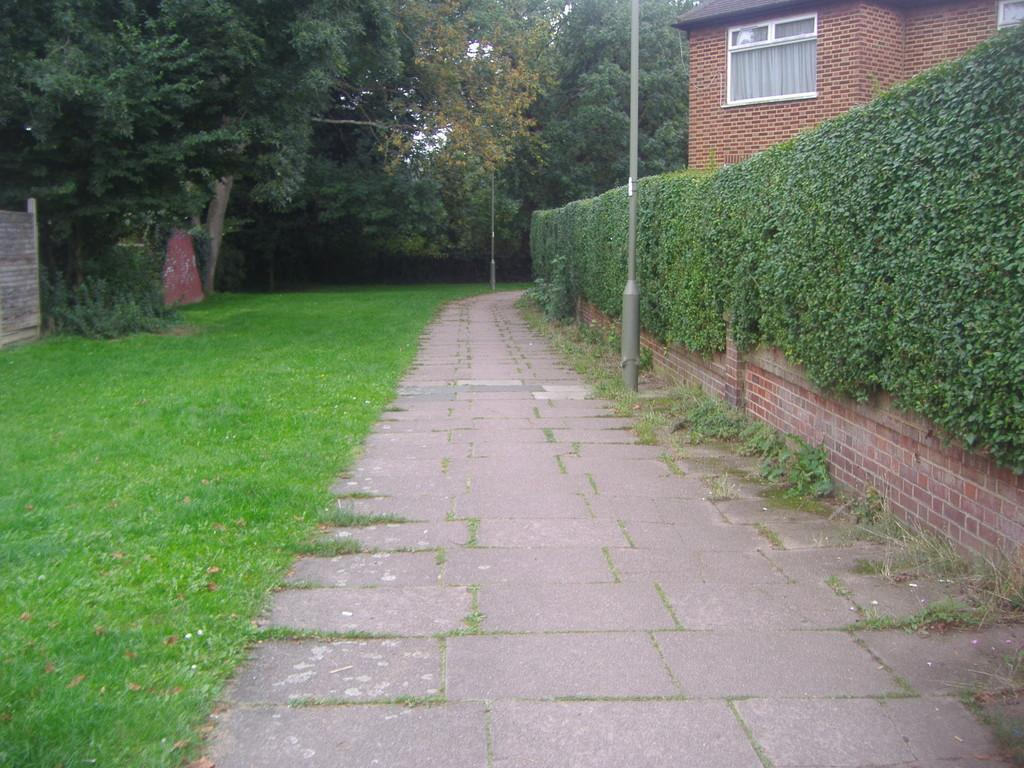What type of vegetation is present on the ground in the image? There is grass on the ground in the image. What other types of vegetation can be seen in the image? There are plants and trees in the image. What structure is visible on the right side of the image? There is a house on the right side of the image. What architectural feature is present on the left side of the image? There is a wall on the left side of the image. What is the pole in the image used for? The purpose of the pole in the image cannot be determined from the provided facts. What type of chairs can be seen in the cemetery in the image? There is no cemetery present in the image, and therefore no chairs can be seen in a cemetery. 